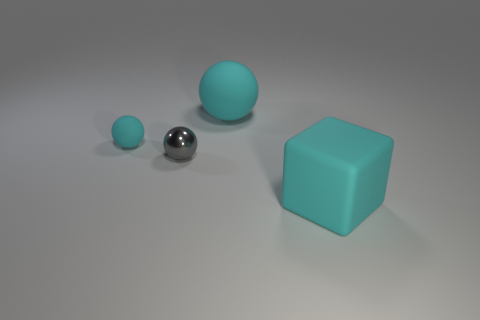What number of small gray spheres have the same material as the small cyan ball?
Your response must be concise. 0. There is a tiny matte object; is it the same color as the large thing in front of the small gray shiny sphere?
Ensure brevity in your answer.  Yes. Is the number of things greater than the number of big cyan cylinders?
Provide a short and direct response. Yes. What is the color of the small matte object?
Provide a short and direct response. Cyan. There is a big matte object that is to the left of the cyan block; is it the same color as the rubber cube?
Give a very brief answer. Yes. There is a small thing that is the same color as the big matte sphere; what is it made of?
Your answer should be compact. Rubber. What number of big matte balls have the same color as the big block?
Ensure brevity in your answer.  1. Do the object to the right of the large rubber sphere and the gray metallic object have the same shape?
Provide a succinct answer. No. Is the number of cyan balls that are to the right of the gray shiny thing less than the number of tiny gray metallic balls to the right of the cyan matte block?
Offer a very short reply. No. What is the big cyan object that is on the left side of the big cyan matte cube made of?
Offer a terse response. Rubber. 